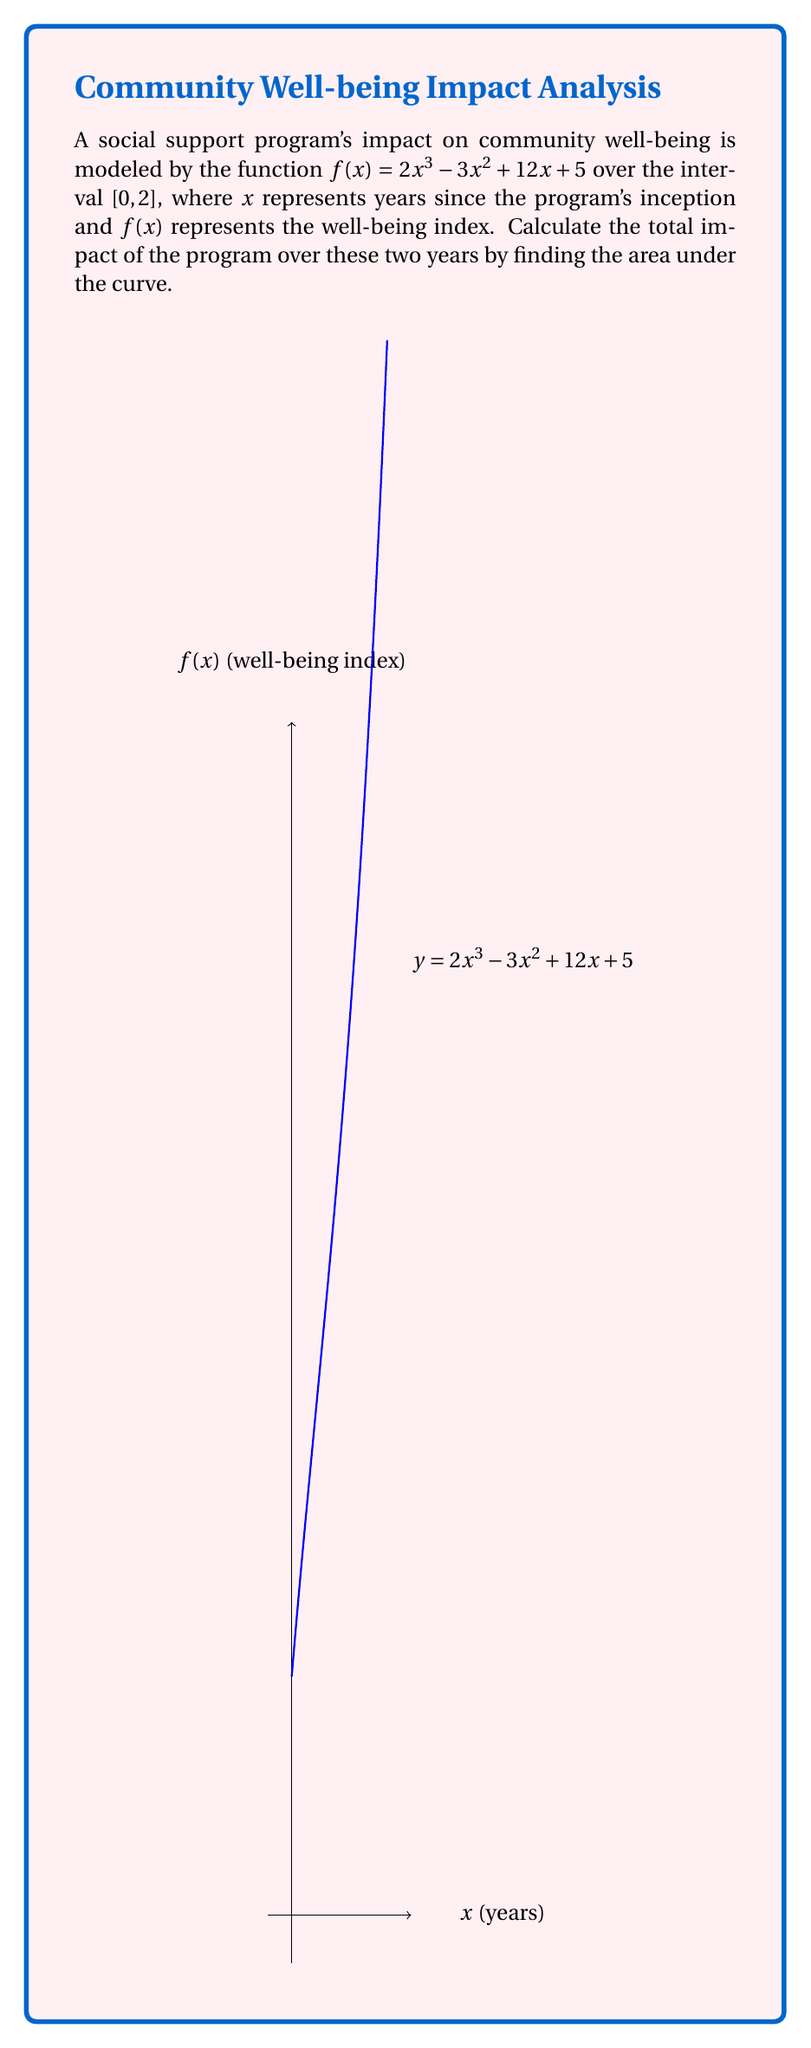Could you help me with this problem? To find the area under the curve, we need to calculate the definite integral of $f(x)$ from 0 to 2.

1) First, let's find the antiderivative $F(x)$ of $f(x)$:
   $F(x) = \int f(x) dx = \int (2x^3 - 3x^2 + 12x + 5) dx$
   $F(x) = \frac{1}{2}x^4 - x^3 + 6x^2 + 5x + C$

2) Now, we can use the Fundamental Theorem of Calculus:
   $\int_0^2 f(x) dx = F(2) - F(0)$

3) Let's calculate $F(2)$ and $F(0)$:
   $F(2) = \frac{1}{2}(2^4) - (2^3) + 6(2^2) + 5(2) + C = 8 - 8 + 24 + 10 + C = 34 + C$
   $F(0) = \frac{1}{2}(0^4) - (0^3) + 6(0^2) + 5(0) + C = 0 + 0 + 0 + 0 + C = C$

4) Now we can subtract:
   $F(2) - F(0) = (34 + C) - C = 34$

Therefore, the total impact of the program over the two years, represented by the area under the curve, is 34 units on the well-being index scale.
Answer: 34 units 